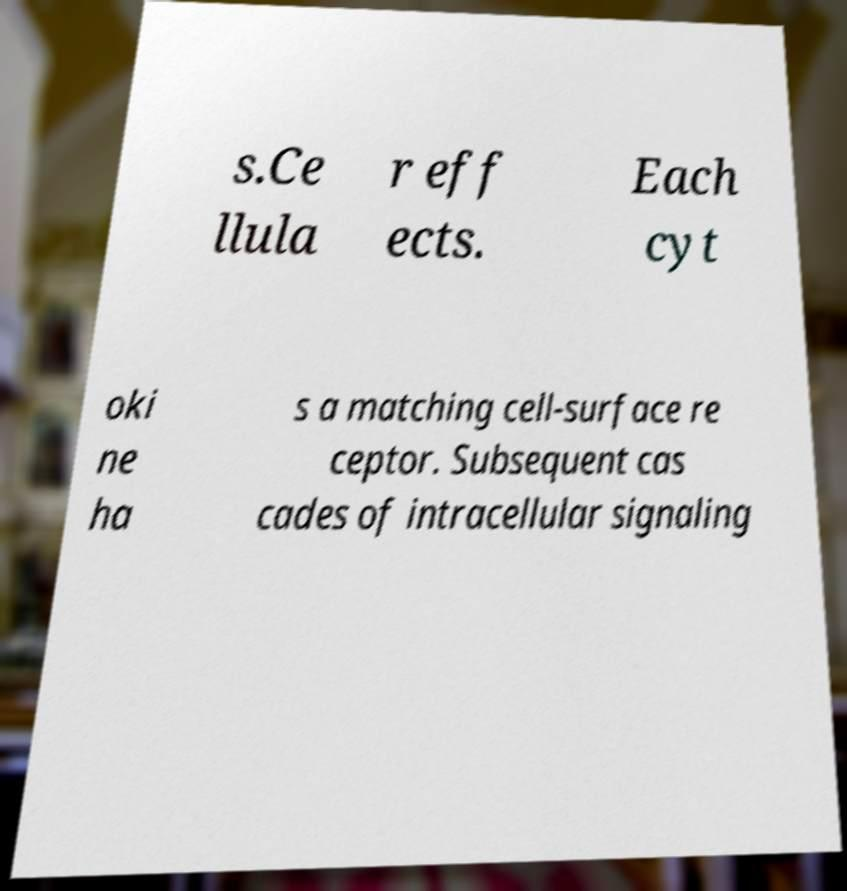There's text embedded in this image that I need extracted. Can you transcribe it verbatim? s.Ce llula r eff ects. Each cyt oki ne ha s a matching cell-surface re ceptor. Subsequent cas cades of intracellular signaling 